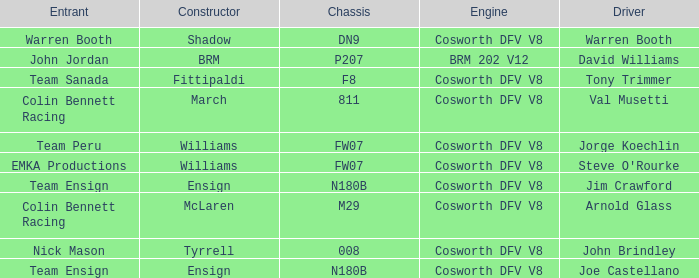Would you mind parsing the complete table? {'header': ['Entrant', 'Constructor', 'Chassis', 'Engine', 'Driver'], 'rows': [['Warren Booth', 'Shadow', 'DN9', 'Cosworth DFV V8', 'Warren Booth'], ['John Jordan', 'BRM', 'P207', 'BRM 202 V12', 'David Williams'], ['Team Sanada', 'Fittipaldi', 'F8', 'Cosworth DFV V8', 'Tony Trimmer'], ['Colin Bennett Racing', 'March', '811', 'Cosworth DFV V8', 'Val Musetti'], ['Team Peru', 'Williams', 'FW07', 'Cosworth DFV V8', 'Jorge Koechlin'], ['EMKA Productions', 'Williams', 'FW07', 'Cosworth DFV V8', "Steve O'Rourke"], ['Team Ensign', 'Ensign', 'N180B', 'Cosworth DFV V8', 'Jim Crawford'], ['Colin Bennett Racing', 'McLaren', 'M29', 'Cosworth DFV V8', 'Arnold Glass'], ['Nick Mason', 'Tyrrell', '008', 'Cosworth DFV V8', 'John Brindley'], ['Team Ensign', 'Ensign', 'N180B', 'Cosworth DFV V8', 'Joe Castellano']]} What team uses a Cosworth DFV V8 engine and DN9 Chassis? Warren Booth. 